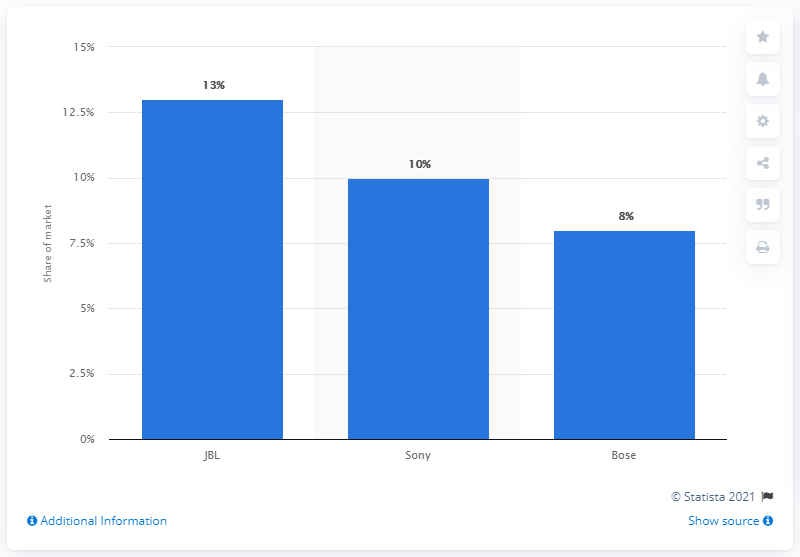Indicate a few pertinent items in this graphic. JBL held 13% of the wireless headphone market in the third quarter of 2019. In the third quarter of 2019, Sony took the second spot in the wireless headphone market. According to the third-quarter market data in 2019, JBL held the greatest share of the wireless headphone market. 